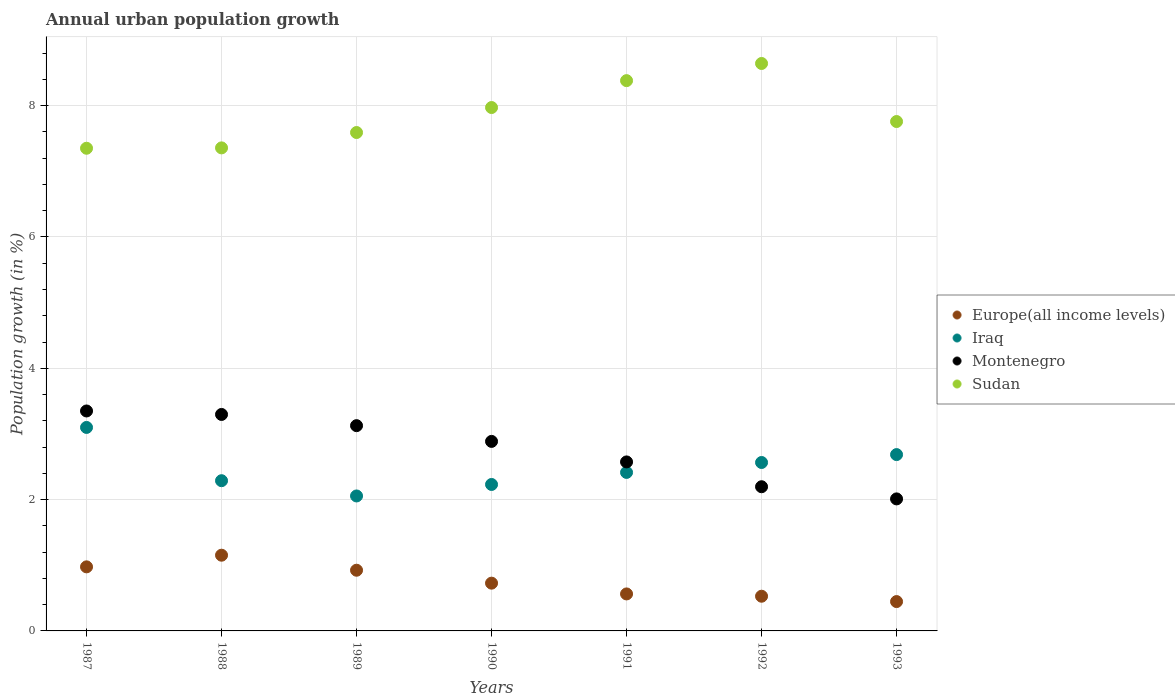Is the number of dotlines equal to the number of legend labels?
Offer a very short reply. Yes. What is the percentage of urban population growth in Europe(all income levels) in 1993?
Your response must be concise. 0.45. Across all years, what is the maximum percentage of urban population growth in Sudan?
Keep it short and to the point. 8.64. Across all years, what is the minimum percentage of urban population growth in Iraq?
Keep it short and to the point. 2.06. In which year was the percentage of urban population growth in Europe(all income levels) maximum?
Your response must be concise. 1988. In which year was the percentage of urban population growth in Montenegro minimum?
Ensure brevity in your answer.  1993. What is the total percentage of urban population growth in Iraq in the graph?
Your answer should be very brief. 17.34. What is the difference between the percentage of urban population growth in Montenegro in 1989 and that in 1990?
Keep it short and to the point. 0.24. What is the difference between the percentage of urban population growth in Iraq in 1989 and the percentage of urban population growth in Montenegro in 1987?
Your answer should be very brief. -1.29. What is the average percentage of urban population growth in Sudan per year?
Ensure brevity in your answer.  7.86. In the year 1988, what is the difference between the percentage of urban population growth in Sudan and percentage of urban population growth in Europe(all income levels)?
Offer a terse response. 6.2. What is the ratio of the percentage of urban population growth in Montenegro in 1987 to that in 1992?
Keep it short and to the point. 1.53. Is the difference between the percentage of urban population growth in Sudan in 1989 and 1993 greater than the difference between the percentage of urban population growth in Europe(all income levels) in 1989 and 1993?
Your answer should be compact. No. What is the difference between the highest and the second highest percentage of urban population growth in Montenegro?
Offer a terse response. 0.05. What is the difference between the highest and the lowest percentage of urban population growth in Sudan?
Keep it short and to the point. 1.29. Is it the case that in every year, the sum of the percentage of urban population growth in Montenegro and percentage of urban population growth in Iraq  is greater than the sum of percentage of urban population growth in Sudan and percentage of urban population growth in Europe(all income levels)?
Your response must be concise. Yes. Is it the case that in every year, the sum of the percentage of urban population growth in Sudan and percentage of urban population growth in Europe(all income levels)  is greater than the percentage of urban population growth in Montenegro?
Provide a short and direct response. Yes. Does the percentage of urban population growth in Sudan monotonically increase over the years?
Provide a succinct answer. No. Is the percentage of urban population growth in Montenegro strictly greater than the percentage of urban population growth in Europe(all income levels) over the years?
Provide a succinct answer. Yes. How many dotlines are there?
Your response must be concise. 4. Are the values on the major ticks of Y-axis written in scientific E-notation?
Offer a terse response. No. Does the graph contain any zero values?
Ensure brevity in your answer.  No. Where does the legend appear in the graph?
Your answer should be very brief. Center right. What is the title of the graph?
Offer a very short reply. Annual urban population growth. Does "Kenya" appear as one of the legend labels in the graph?
Offer a terse response. No. What is the label or title of the X-axis?
Keep it short and to the point. Years. What is the label or title of the Y-axis?
Your answer should be very brief. Population growth (in %). What is the Population growth (in %) of Europe(all income levels) in 1987?
Your answer should be compact. 0.98. What is the Population growth (in %) of Iraq in 1987?
Provide a short and direct response. 3.1. What is the Population growth (in %) of Montenegro in 1987?
Offer a terse response. 3.35. What is the Population growth (in %) of Sudan in 1987?
Give a very brief answer. 7.35. What is the Population growth (in %) of Europe(all income levels) in 1988?
Your response must be concise. 1.15. What is the Population growth (in %) in Iraq in 1988?
Offer a very short reply. 2.29. What is the Population growth (in %) of Montenegro in 1988?
Your answer should be compact. 3.3. What is the Population growth (in %) in Sudan in 1988?
Make the answer very short. 7.36. What is the Population growth (in %) of Europe(all income levels) in 1989?
Offer a very short reply. 0.92. What is the Population growth (in %) in Iraq in 1989?
Provide a short and direct response. 2.06. What is the Population growth (in %) of Montenegro in 1989?
Keep it short and to the point. 3.13. What is the Population growth (in %) in Sudan in 1989?
Give a very brief answer. 7.59. What is the Population growth (in %) in Europe(all income levels) in 1990?
Offer a terse response. 0.73. What is the Population growth (in %) in Iraq in 1990?
Your response must be concise. 2.23. What is the Population growth (in %) of Montenegro in 1990?
Provide a short and direct response. 2.89. What is the Population growth (in %) in Sudan in 1990?
Make the answer very short. 7.97. What is the Population growth (in %) of Europe(all income levels) in 1991?
Your answer should be very brief. 0.56. What is the Population growth (in %) of Iraq in 1991?
Offer a very short reply. 2.41. What is the Population growth (in %) in Montenegro in 1991?
Your answer should be very brief. 2.57. What is the Population growth (in %) of Sudan in 1991?
Offer a very short reply. 8.38. What is the Population growth (in %) of Europe(all income levels) in 1992?
Your answer should be compact. 0.53. What is the Population growth (in %) of Iraq in 1992?
Keep it short and to the point. 2.57. What is the Population growth (in %) in Montenegro in 1992?
Offer a very short reply. 2.2. What is the Population growth (in %) of Sudan in 1992?
Provide a succinct answer. 8.64. What is the Population growth (in %) of Europe(all income levels) in 1993?
Offer a very short reply. 0.45. What is the Population growth (in %) in Iraq in 1993?
Give a very brief answer. 2.69. What is the Population growth (in %) of Montenegro in 1993?
Your answer should be compact. 2.01. What is the Population growth (in %) in Sudan in 1993?
Offer a very short reply. 7.76. Across all years, what is the maximum Population growth (in %) of Europe(all income levels)?
Keep it short and to the point. 1.15. Across all years, what is the maximum Population growth (in %) of Iraq?
Make the answer very short. 3.1. Across all years, what is the maximum Population growth (in %) in Montenegro?
Your answer should be very brief. 3.35. Across all years, what is the maximum Population growth (in %) of Sudan?
Provide a short and direct response. 8.64. Across all years, what is the minimum Population growth (in %) of Europe(all income levels)?
Offer a terse response. 0.45. Across all years, what is the minimum Population growth (in %) of Iraq?
Your response must be concise. 2.06. Across all years, what is the minimum Population growth (in %) of Montenegro?
Offer a terse response. 2.01. Across all years, what is the minimum Population growth (in %) in Sudan?
Your answer should be very brief. 7.35. What is the total Population growth (in %) of Europe(all income levels) in the graph?
Your response must be concise. 5.32. What is the total Population growth (in %) in Iraq in the graph?
Keep it short and to the point. 17.34. What is the total Population growth (in %) in Montenegro in the graph?
Your answer should be compact. 19.44. What is the total Population growth (in %) in Sudan in the graph?
Provide a succinct answer. 55.05. What is the difference between the Population growth (in %) in Europe(all income levels) in 1987 and that in 1988?
Provide a succinct answer. -0.18. What is the difference between the Population growth (in %) of Iraq in 1987 and that in 1988?
Make the answer very short. 0.81. What is the difference between the Population growth (in %) of Montenegro in 1987 and that in 1988?
Your answer should be very brief. 0.05. What is the difference between the Population growth (in %) of Sudan in 1987 and that in 1988?
Give a very brief answer. -0.01. What is the difference between the Population growth (in %) in Europe(all income levels) in 1987 and that in 1989?
Provide a short and direct response. 0.05. What is the difference between the Population growth (in %) of Iraq in 1987 and that in 1989?
Ensure brevity in your answer.  1.04. What is the difference between the Population growth (in %) of Montenegro in 1987 and that in 1989?
Your response must be concise. 0.22. What is the difference between the Population growth (in %) in Sudan in 1987 and that in 1989?
Keep it short and to the point. -0.24. What is the difference between the Population growth (in %) in Europe(all income levels) in 1987 and that in 1990?
Your answer should be very brief. 0.25. What is the difference between the Population growth (in %) in Iraq in 1987 and that in 1990?
Your answer should be very brief. 0.87. What is the difference between the Population growth (in %) of Montenegro in 1987 and that in 1990?
Your answer should be very brief. 0.46. What is the difference between the Population growth (in %) in Sudan in 1987 and that in 1990?
Offer a very short reply. -0.62. What is the difference between the Population growth (in %) of Europe(all income levels) in 1987 and that in 1991?
Keep it short and to the point. 0.41. What is the difference between the Population growth (in %) in Iraq in 1987 and that in 1991?
Give a very brief answer. 0.69. What is the difference between the Population growth (in %) of Montenegro in 1987 and that in 1991?
Your answer should be very brief. 0.78. What is the difference between the Population growth (in %) of Sudan in 1987 and that in 1991?
Your answer should be compact. -1.03. What is the difference between the Population growth (in %) of Europe(all income levels) in 1987 and that in 1992?
Make the answer very short. 0.45. What is the difference between the Population growth (in %) in Iraq in 1987 and that in 1992?
Keep it short and to the point. 0.53. What is the difference between the Population growth (in %) in Montenegro in 1987 and that in 1992?
Your response must be concise. 1.15. What is the difference between the Population growth (in %) of Sudan in 1987 and that in 1992?
Your answer should be compact. -1.29. What is the difference between the Population growth (in %) in Europe(all income levels) in 1987 and that in 1993?
Ensure brevity in your answer.  0.53. What is the difference between the Population growth (in %) of Iraq in 1987 and that in 1993?
Offer a terse response. 0.41. What is the difference between the Population growth (in %) of Montenegro in 1987 and that in 1993?
Keep it short and to the point. 1.34. What is the difference between the Population growth (in %) in Sudan in 1987 and that in 1993?
Offer a very short reply. -0.41. What is the difference between the Population growth (in %) in Europe(all income levels) in 1988 and that in 1989?
Keep it short and to the point. 0.23. What is the difference between the Population growth (in %) in Iraq in 1988 and that in 1989?
Your answer should be very brief. 0.23. What is the difference between the Population growth (in %) in Montenegro in 1988 and that in 1989?
Your response must be concise. 0.17. What is the difference between the Population growth (in %) in Sudan in 1988 and that in 1989?
Your answer should be very brief. -0.23. What is the difference between the Population growth (in %) in Europe(all income levels) in 1988 and that in 1990?
Offer a terse response. 0.43. What is the difference between the Population growth (in %) of Iraq in 1988 and that in 1990?
Offer a terse response. 0.06. What is the difference between the Population growth (in %) in Montenegro in 1988 and that in 1990?
Your answer should be compact. 0.41. What is the difference between the Population growth (in %) in Sudan in 1988 and that in 1990?
Provide a short and direct response. -0.61. What is the difference between the Population growth (in %) in Europe(all income levels) in 1988 and that in 1991?
Give a very brief answer. 0.59. What is the difference between the Population growth (in %) of Iraq in 1988 and that in 1991?
Provide a short and direct response. -0.13. What is the difference between the Population growth (in %) in Montenegro in 1988 and that in 1991?
Provide a short and direct response. 0.72. What is the difference between the Population growth (in %) of Sudan in 1988 and that in 1991?
Your answer should be very brief. -1.02. What is the difference between the Population growth (in %) of Europe(all income levels) in 1988 and that in 1992?
Keep it short and to the point. 0.62. What is the difference between the Population growth (in %) in Iraq in 1988 and that in 1992?
Your response must be concise. -0.28. What is the difference between the Population growth (in %) of Montenegro in 1988 and that in 1992?
Your answer should be very brief. 1.1. What is the difference between the Population growth (in %) in Sudan in 1988 and that in 1992?
Keep it short and to the point. -1.29. What is the difference between the Population growth (in %) in Europe(all income levels) in 1988 and that in 1993?
Make the answer very short. 0.71. What is the difference between the Population growth (in %) of Iraq in 1988 and that in 1993?
Ensure brevity in your answer.  -0.4. What is the difference between the Population growth (in %) of Montenegro in 1988 and that in 1993?
Ensure brevity in your answer.  1.29. What is the difference between the Population growth (in %) of Sudan in 1988 and that in 1993?
Give a very brief answer. -0.4. What is the difference between the Population growth (in %) of Europe(all income levels) in 1989 and that in 1990?
Offer a very short reply. 0.2. What is the difference between the Population growth (in %) in Iraq in 1989 and that in 1990?
Offer a terse response. -0.17. What is the difference between the Population growth (in %) in Montenegro in 1989 and that in 1990?
Give a very brief answer. 0.24. What is the difference between the Population growth (in %) in Sudan in 1989 and that in 1990?
Your answer should be very brief. -0.38. What is the difference between the Population growth (in %) in Europe(all income levels) in 1989 and that in 1991?
Provide a short and direct response. 0.36. What is the difference between the Population growth (in %) of Iraq in 1989 and that in 1991?
Provide a short and direct response. -0.36. What is the difference between the Population growth (in %) of Montenegro in 1989 and that in 1991?
Offer a terse response. 0.55. What is the difference between the Population growth (in %) of Sudan in 1989 and that in 1991?
Give a very brief answer. -0.79. What is the difference between the Population growth (in %) in Europe(all income levels) in 1989 and that in 1992?
Ensure brevity in your answer.  0.4. What is the difference between the Population growth (in %) of Iraq in 1989 and that in 1992?
Ensure brevity in your answer.  -0.51. What is the difference between the Population growth (in %) in Montenegro in 1989 and that in 1992?
Give a very brief answer. 0.93. What is the difference between the Population growth (in %) of Sudan in 1989 and that in 1992?
Give a very brief answer. -1.05. What is the difference between the Population growth (in %) in Europe(all income levels) in 1989 and that in 1993?
Provide a short and direct response. 0.48. What is the difference between the Population growth (in %) in Iraq in 1989 and that in 1993?
Your answer should be very brief. -0.63. What is the difference between the Population growth (in %) in Montenegro in 1989 and that in 1993?
Offer a terse response. 1.12. What is the difference between the Population growth (in %) of Sudan in 1989 and that in 1993?
Offer a terse response. -0.17. What is the difference between the Population growth (in %) of Europe(all income levels) in 1990 and that in 1991?
Your answer should be very brief. 0.16. What is the difference between the Population growth (in %) in Iraq in 1990 and that in 1991?
Offer a terse response. -0.18. What is the difference between the Population growth (in %) in Montenegro in 1990 and that in 1991?
Your answer should be very brief. 0.31. What is the difference between the Population growth (in %) of Sudan in 1990 and that in 1991?
Provide a succinct answer. -0.41. What is the difference between the Population growth (in %) in Europe(all income levels) in 1990 and that in 1992?
Provide a succinct answer. 0.2. What is the difference between the Population growth (in %) in Iraq in 1990 and that in 1992?
Provide a succinct answer. -0.33. What is the difference between the Population growth (in %) of Montenegro in 1990 and that in 1992?
Offer a terse response. 0.69. What is the difference between the Population growth (in %) in Sudan in 1990 and that in 1992?
Your answer should be very brief. -0.67. What is the difference between the Population growth (in %) of Europe(all income levels) in 1990 and that in 1993?
Your response must be concise. 0.28. What is the difference between the Population growth (in %) in Iraq in 1990 and that in 1993?
Ensure brevity in your answer.  -0.46. What is the difference between the Population growth (in %) of Montenegro in 1990 and that in 1993?
Ensure brevity in your answer.  0.88. What is the difference between the Population growth (in %) in Sudan in 1990 and that in 1993?
Offer a very short reply. 0.21. What is the difference between the Population growth (in %) of Europe(all income levels) in 1991 and that in 1992?
Keep it short and to the point. 0.03. What is the difference between the Population growth (in %) in Iraq in 1991 and that in 1992?
Offer a terse response. -0.15. What is the difference between the Population growth (in %) in Montenegro in 1991 and that in 1992?
Keep it short and to the point. 0.38. What is the difference between the Population growth (in %) in Sudan in 1991 and that in 1992?
Provide a short and direct response. -0.26. What is the difference between the Population growth (in %) in Europe(all income levels) in 1991 and that in 1993?
Your answer should be compact. 0.12. What is the difference between the Population growth (in %) of Iraq in 1991 and that in 1993?
Make the answer very short. -0.27. What is the difference between the Population growth (in %) of Montenegro in 1991 and that in 1993?
Your answer should be compact. 0.56. What is the difference between the Population growth (in %) in Sudan in 1991 and that in 1993?
Your answer should be very brief. 0.62. What is the difference between the Population growth (in %) of Europe(all income levels) in 1992 and that in 1993?
Provide a short and direct response. 0.08. What is the difference between the Population growth (in %) of Iraq in 1992 and that in 1993?
Ensure brevity in your answer.  -0.12. What is the difference between the Population growth (in %) of Montenegro in 1992 and that in 1993?
Make the answer very short. 0.19. What is the difference between the Population growth (in %) of Sudan in 1992 and that in 1993?
Offer a terse response. 0.88. What is the difference between the Population growth (in %) in Europe(all income levels) in 1987 and the Population growth (in %) in Iraq in 1988?
Offer a terse response. -1.31. What is the difference between the Population growth (in %) in Europe(all income levels) in 1987 and the Population growth (in %) in Montenegro in 1988?
Your answer should be very brief. -2.32. What is the difference between the Population growth (in %) in Europe(all income levels) in 1987 and the Population growth (in %) in Sudan in 1988?
Your answer should be very brief. -6.38. What is the difference between the Population growth (in %) of Iraq in 1987 and the Population growth (in %) of Montenegro in 1988?
Provide a succinct answer. -0.2. What is the difference between the Population growth (in %) of Iraq in 1987 and the Population growth (in %) of Sudan in 1988?
Offer a terse response. -4.26. What is the difference between the Population growth (in %) of Montenegro in 1987 and the Population growth (in %) of Sudan in 1988?
Offer a terse response. -4.01. What is the difference between the Population growth (in %) in Europe(all income levels) in 1987 and the Population growth (in %) in Iraq in 1989?
Provide a succinct answer. -1.08. What is the difference between the Population growth (in %) of Europe(all income levels) in 1987 and the Population growth (in %) of Montenegro in 1989?
Provide a short and direct response. -2.15. What is the difference between the Population growth (in %) of Europe(all income levels) in 1987 and the Population growth (in %) of Sudan in 1989?
Offer a terse response. -6.61. What is the difference between the Population growth (in %) of Iraq in 1987 and the Population growth (in %) of Montenegro in 1989?
Your answer should be very brief. -0.03. What is the difference between the Population growth (in %) of Iraq in 1987 and the Population growth (in %) of Sudan in 1989?
Your response must be concise. -4.49. What is the difference between the Population growth (in %) of Montenegro in 1987 and the Population growth (in %) of Sudan in 1989?
Offer a terse response. -4.24. What is the difference between the Population growth (in %) in Europe(all income levels) in 1987 and the Population growth (in %) in Iraq in 1990?
Your response must be concise. -1.25. What is the difference between the Population growth (in %) of Europe(all income levels) in 1987 and the Population growth (in %) of Montenegro in 1990?
Provide a succinct answer. -1.91. What is the difference between the Population growth (in %) of Europe(all income levels) in 1987 and the Population growth (in %) of Sudan in 1990?
Offer a terse response. -7. What is the difference between the Population growth (in %) in Iraq in 1987 and the Population growth (in %) in Montenegro in 1990?
Your answer should be very brief. 0.21. What is the difference between the Population growth (in %) in Iraq in 1987 and the Population growth (in %) in Sudan in 1990?
Make the answer very short. -4.87. What is the difference between the Population growth (in %) of Montenegro in 1987 and the Population growth (in %) of Sudan in 1990?
Keep it short and to the point. -4.62. What is the difference between the Population growth (in %) in Europe(all income levels) in 1987 and the Population growth (in %) in Iraq in 1991?
Provide a short and direct response. -1.44. What is the difference between the Population growth (in %) of Europe(all income levels) in 1987 and the Population growth (in %) of Montenegro in 1991?
Provide a short and direct response. -1.6. What is the difference between the Population growth (in %) in Europe(all income levels) in 1987 and the Population growth (in %) in Sudan in 1991?
Ensure brevity in your answer.  -7.41. What is the difference between the Population growth (in %) of Iraq in 1987 and the Population growth (in %) of Montenegro in 1991?
Your response must be concise. 0.53. What is the difference between the Population growth (in %) in Iraq in 1987 and the Population growth (in %) in Sudan in 1991?
Keep it short and to the point. -5.28. What is the difference between the Population growth (in %) in Montenegro in 1987 and the Population growth (in %) in Sudan in 1991?
Ensure brevity in your answer.  -5.03. What is the difference between the Population growth (in %) of Europe(all income levels) in 1987 and the Population growth (in %) of Iraq in 1992?
Ensure brevity in your answer.  -1.59. What is the difference between the Population growth (in %) of Europe(all income levels) in 1987 and the Population growth (in %) of Montenegro in 1992?
Offer a terse response. -1.22. What is the difference between the Population growth (in %) of Europe(all income levels) in 1987 and the Population growth (in %) of Sudan in 1992?
Your answer should be very brief. -7.67. What is the difference between the Population growth (in %) in Iraq in 1987 and the Population growth (in %) in Montenegro in 1992?
Your answer should be very brief. 0.9. What is the difference between the Population growth (in %) of Iraq in 1987 and the Population growth (in %) of Sudan in 1992?
Make the answer very short. -5.54. What is the difference between the Population growth (in %) of Montenegro in 1987 and the Population growth (in %) of Sudan in 1992?
Ensure brevity in your answer.  -5.29. What is the difference between the Population growth (in %) of Europe(all income levels) in 1987 and the Population growth (in %) of Iraq in 1993?
Provide a succinct answer. -1.71. What is the difference between the Population growth (in %) of Europe(all income levels) in 1987 and the Population growth (in %) of Montenegro in 1993?
Your answer should be very brief. -1.03. What is the difference between the Population growth (in %) of Europe(all income levels) in 1987 and the Population growth (in %) of Sudan in 1993?
Ensure brevity in your answer.  -6.78. What is the difference between the Population growth (in %) of Iraq in 1987 and the Population growth (in %) of Montenegro in 1993?
Your response must be concise. 1.09. What is the difference between the Population growth (in %) in Iraq in 1987 and the Population growth (in %) in Sudan in 1993?
Your response must be concise. -4.66. What is the difference between the Population growth (in %) in Montenegro in 1987 and the Population growth (in %) in Sudan in 1993?
Your response must be concise. -4.41. What is the difference between the Population growth (in %) in Europe(all income levels) in 1988 and the Population growth (in %) in Iraq in 1989?
Your response must be concise. -0.9. What is the difference between the Population growth (in %) in Europe(all income levels) in 1988 and the Population growth (in %) in Montenegro in 1989?
Your answer should be compact. -1.97. What is the difference between the Population growth (in %) in Europe(all income levels) in 1988 and the Population growth (in %) in Sudan in 1989?
Your answer should be compact. -6.44. What is the difference between the Population growth (in %) in Iraq in 1988 and the Population growth (in %) in Montenegro in 1989?
Make the answer very short. -0.84. What is the difference between the Population growth (in %) in Iraq in 1988 and the Population growth (in %) in Sudan in 1989?
Give a very brief answer. -5.3. What is the difference between the Population growth (in %) in Montenegro in 1988 and the Population growth (in %) in Sudan in 1989?
Provide a short and direct response. -4.29. What is the difference between the Population growth (in %) in Europe(all income levels) in 1988 and the Population growth (in %) in Iraq in 1990?
Give a very brief answer. -1.08. What is the difference between the Population growth (in %) of Europe(all income levels) in 1988 and the Population growth (in %) of Montenegro in 1990?
Offer a terse response. -1.73. What is the difference between the Population growth (in %) in Europe(all income levels) in 1988 and the Population growth (in %) in Sudan in 1990?
Ensure brevity in your answer.  -6.82. What is the difference between the Population growth (in %) in Iraq in 1988 and the Population growth (in %) in Montenegro in 1990?
Your answer should be very brief. -0.6. What is the difference between the Population growth (in %) of Iraq in 1988 and the Population growth (in %) of Sudan in 1990?
Your response must be concise. -5.68. What is the difference between the Population growth (in %) in Montenegro in 1988 and the Population growth (in %) in Sudan in 1990?
Make the answer very short. -4.67. What is the difference between the Population growth (in %) in Europe(all income levels) in 1988 and the Population growth (in %) in Iraq in 1991?
Your answer should be compact. -1.26. What is the difference between the Population growth (in %) in Europe(all income levels) in 1988 and the Population growth (in %) in Montenegro in 1991?
Provide a succinct answer. -1.42. What is the difference between the Population growth (in %) of Europe(all income levels) in 1988 and the Population growth (in %) of Sudan in 1991?
Give a very brief answer. -7.23. What is the difference between the Population growth (in %) of Iraq in 1988 and the Population growth (in %) of Montenegro in 1991?
Your answer should be very brief. -0.29. What is the difference between the Population growth (in %) of Iraq in 1988 and the Population growth (in %) of Sudan in 1991?
Your response must be concise. -6.09. What is the difference between the Population growth (in %) of Montenegro in 1988 and the Population growth (in %) of Sudan in 1991?
Make the answer very short. -5.08. What is the difference between the Population growth (in %) of Europe(all income levels) in 1988 and the Population growth (in %) of Iraq in 1992?
Make the answer very short. -1.41. What is the difference between the Population growth (in %) in Europe(all income levels) in 1988 and the Population growth (in %) in Montenegro in 1992?
Keep it short and to the point. -1.04. What is the difference between the Population growth (in %) of Europe(all income levels) in 1988 and the Population growth (in %) of Sudan in 1992?
Provide a short and direct response. -7.49. What is the difference between the Population growth (in %) of Iraq in 1988 and the Population growth (in %) of Montenegro in 1992?
Provide a succinct answer. 0.09. What is the difference between the Population growth (in %) in Iraq in 1988 and the Population growth (in %) in Sudan in 1992?
Your answer should be compact. -6.35. What is the difference between the Population growth (in %) in Montenegro in 1988 and the Population growth (in %) in Sudan in 1992?
Provide a short and direct response. -5.35. What is the difference between the Population growth (in %) in Europe(all income levels) in 1988 and the Population growth (in %) in Iraq in 1993?
Give a very brief answer. -1.53. What is the difference between the Population growth (in %) of Europe(all income levels) in 1988 and the Population growth (in %) of Montenegro in 1993?
Your answer should be very brief. -0.86. What is the difference between the Population growth (in %) of Europe(all income levels) in 1988 and the Population growth (in %) of Sudan in 1993?
Ensure brevity in your answer.  -6.6. What is the difference between the Population growth (in %) of Iraq in 1988 and the Population growth (in %) of Montenegro in 1993?
Keep it short and to the point. 0.28. What is the difference between the Population growth (in %) in Iraq in 1988 and the Population growth (in %) in Sudan in 1993?
Ensure brevity in your answer.  -5.47. What is the difference between the Population growth (in %) in Montenegro in 1988 and the Population growth (in %) in Sudan in 1993?
Give a very brief answer. -4.46. What is the difference between the Population growth (in %) in Europe(all income levels) in 1989 and the Population growth (in %) in Iraq in 1990?
Offer a very short reply. -1.31. What is the difference between the Population growth (in %) of Europe(all income levels) in 1989 and the Population growth (in %) of Montenegro in 1990?
Make the answer very short. -1.96. What is the difference between the Population growth (in %) in Europe(all income levels) in 1989 and the Population growth (in %) in Sudan in 1990?
Your response must be concise. -7.05. What is the difference between the Population growth (in %) of Iraq in 1989 and the Population growth (in %) of Montenegro in 1990?
Ensure brevity in your answer.  -0.83. What is the difference between the Population growth (in %) of Iraq in 1989 and the Population growth (in %) of Sudan in 1990?
Your answer should be very brief. -5.92. What is the difference between the Population growth (in %) in Montenegro in 1989 and the Population growth (in %) in Sudan in 1990?
Ensure brevity in your answer.  -4.85. What is the difference between the Population growth (in %) in Europe(all income levels) in 1989 and the Population growth (in %) in Iraq in 1991?
Keep it short and to the point. -1.49. What is the difference between the Population growth (in %) in Europe(all income levels) in 1989 and the Population growth (in %) in Montenegro in 1991?
Offer a terse response. -1.65. What is the difference between the Population growth (in %) of Europe(all income levels) in 1989 and the Population growth (in %) of Sudan in 1991?
Give a very brief answer. -7.46. What is the difference between the Population growth (in %) in Iraq in 1989 and the Population growth (in %) in Montenegro in 1991?
Ensure brevity in your answer.  -0.52. What is the difference between the Population growth (in %) of Iraq in 1989 and the Population growth (in %) of Sudan in 1991?
Provide a succinct answer. -6.33. What is the difference between the Population growth (in %) of Montenegro in 1989 and the Population growth (in %) of Sudan in 1991?
Give a very brief answer. -5.25. What is the difference between the Population growth (in %) in Europe(all income levels) in 1989 and the Population growth (in %) in Iraq in 1992?
Give a very brief answer. -1.64. What is the difference between the Population growth (in %) in Europe(all income levels) in 1989 and the Population growth (in %) in Montenegro in 1992?
Ensure brevity in your answer.  -1.27. What is the difference between the Population growth (in %) in Europe(all income levels) in 1989 and the Population growth (in %) in Sudan in 1992?
Keep it short and to the point. -7.72. What is the difference between the Population growth (in %) of Iraq in 1989 and the Population growth (in %) of Montenegro in 1992?
Ensure brevity in your answer.  -0.14. What is the difference between the Population growth (in %) of Iraq in 1989 and the Population growth (in %) of Sudan in 1992?
Provide a succinct answer. -6.59. What is the difference between the Population growth (in %) in Montenegro in 1989 and the Population growth (in %) in Sudan in 1992?
Give a very brief answer. -5.52. What is the difference between the Population growth (in %) of Europe(all income levels) in 1989 and the Population growth (in %) of Iraq in 1993?
Your answer should be compact. -1.76. What is the difference between the Population growth (in %) of Europe(all income levels) in 1989 and the Population growth (in %) of Montenegro in 1993?
Your answer should be compact. -1.09. What is the difference between the Population growth (in %) of Europe(all income levels) in 1989 and the Population growth (in %) of Sudan in 1993?
Offer a terse response. -6.83. What is the difference between the Population growth (in %) in Iraq in 1989 and the Population growth (in %) in Montenegro in 1993?
Make the answer very short. 0.04. What is the difference between the Population growth (in %) of Iraq in 1989 and the Population growth (in %) of Sudan in 1993?
Keep it short and to the point. -5.7. What is the difference between the Population growth (in %) of Montenegro in 1989 and the Population growth (in %) of Sudan in 1993?
Give a very brief answer. -4.63. What is the difference between the Population growth (in %) of Europe(all income levels) in 1990 and the Population growth (in %) of Iraq in 1991?
Give a very brief answer. -1.69. What is the difference between the Population growth (in %) of Europe(all income levels) in 1990 and the Population growth (in %) of Montenegro in 1991?
Your answer should be compact. -1.85. What is the difference between the Population growth (in %) of Europe(all income levels) in 1990 and the Population growth (in %) of Sudan in 1991?
Keep it short and to the point. -7.65. What is the difference between the Population growth (in %) of Iraq in 1990 and the Population growth (in %) of Montenegro in 1991?
Offer a very short reply. -0.34. What is the difference between the Population growth (in %) of Iraq in 1990 and the Population growth (in %) of Sudan in 1991?
Give a very brief answer. -6.15. What is the difference between the Population growth (in %) in Montenegro in 1990 and the Population growth (in %) in Sudan in 1991?
Your answer should be very brief. -5.49. What is the difference between the Population growth (in %) in Europe(all income levels) in 1990 and the Population growth (in %) in Iraq in 1992?
Make the answer very short. -1.84. What is the difference between the Population growth (in %) of Europe(all income levels) in 1990 and the Population growth (in %) of Montenegro in 1992?
Keep it short and to the point. -1.47. What is the difference between the Population growth (in %) of Europe(all income levels) in 1990 and the Population growth (in %) of Sudan in 1992?
Your answer should be very brief. -7.91. What is the difference between the Population growth (in %) in Iraq in 1990 and the Population growth (in %) in Montenegro in 1992?
Provide a succinct answer. 0.03. What is the difference between the Population growth (in %) in Iraq in 1990 and the Population growth (in %) in Sudan in 1992?
Provide a succinct answer. -6.41. What is the difference between the Population growth (in %) in Montenegro in 1990 and the Population growth (in %) in Sudan in 1992?
Your response must be concise. -5.76. What is the difference between the Population growth (in %) in Europe(all income levels) in 1990 and the Population growth (in %) in Iraq in 1993?
Keep it short and to the point. -1.96. What is the difference between the Population growth (in %) of Europe(all income levels) in 1990 and the Population growth (in %) of Montenegro in 1993?
Offer a terse response. -1.28. What is the difference between the Population growth (in %) of Europe(all income levels) in 1990 and the Population growth (in %) of Sudan in 1993?
Your answer should be compact. -7.03. What is the difference between the Population growth (in %) in Iraq in 1990 and the Population growth (in %) in Montenegro in 1993?
Keep it short and to the point. 0.22. What is the difference between the Population growth (in %) in Iraq in 1990 and the Population growth (in %) in Sudan in 1993?
Your response must be concise. -5.53. What is the difference between the Population growth (in %) of Montenegro in 1990 and the Population growth (in %) of Sudan in 1993?
Offer a terse response. -4.87. What is the difference between the Population growth (in %) of Europe(all income levels) in 1991 and the Population growth (in %) of Iraq in 1992?
Offer a terse response. -2. What is the difference between the Population growth (in %) in Europe(all income levels) in 1991 and the Population growth (in %) in Montenegro in 1992?
Provide a short and direct response. -1.63. What is the difference between the Population growth (in %) of Europe(all income levels) in 1991 and the Population growth (in %) of Sudan in 1992?
Ensure brevity in your answer.  -8.08. What is the difference between the Population growth (in %) in Iraq in 1991 and the Population growth (in %) in Montenegro in 1992?
Provide a short and direct response. 0.22. What is the difference between the Population growth (in %) of Iraq in 1991 and the Population growth (in %) of Sudan in 1992?
Offer a very short reply. -6.23. What is the difference between the Population growth (in %) of Montenegro in 1991 and the Population growth (in %) of Sudan in 1992?
Give a very brief answer. -6.07. What is the difference between the Population growth (in %) in Europe(all income levels) in 1991 and the Population growth (in %) in Iraq in 1993?
Provide a succinct answer. -2.12. What is the difference between the Population growth (in %) in Europe(all income levels) in 1991 and the Population growth (in %) in Montenegro in 1993?
Make the answer very short. -1.45. What is the difference between the Population growth (in %) of Europe(all income levels) in 1991 and the Population growth (in %) of Sudan in 1993?
Your answer should be compact. -7.19. What is the difference between the Population growth (in %) in Iraq in 1991 and the Population growth (in %) in Montenegro in 1993?
Keep it short and to the point. 0.4. What is the difference between the Population growth (in %) in Iraq in 1991 and the Population growth (in %) in Sudan in 1993?
Ensure brevity in your answer.  -5.34. What is the difference between the Population growth (in %) in Montenegro in 1991 and the Population growth (in %) in Sudan in 1993?
Your response must be concise. -5.18. What is the difference between the Population growth (in %) of Europe(all income levels) in 1992 and the Population growth (in %) of Iraq in 1993?
Your response must be concise. -2.16. What is the difference between the Population growth (in %) of Europe(all income levels) in 1992 and the Population growth (in %) of Montenegro in 1993?
Your response must be concise. -1.48. What is the difference between the Population growth (in %) in Europe(all income levels) in 1992 and the Population growth (in %) in Sudan in 1993?
Your answer should be very brief. -7.23. What is the difference between the Population growth (in %) in Iraq in 1992 and the Population growth (in %) in Montenegro in 1993?
Your answer should be very brief. 0.55. What is the difference between the Population growth (in %) of Iraq in 1992 and the Population growth (in %) of Sudan in 1993?
Keep it short and to the point. -5.19. What is the difference between the Population growth (in %) of Montenegro in 1992 and the Population growth (in %) of Sudan in 1993?
Offer a terse response. -5.56. What is the average Population growth (in %) of Europe(all income levels) per year?
Keep it short and to the point. 0.76. What is the average Population growth (in %) of Iraq per year?
Keep it short and to the point. 2.48. What is the average Population growth (in %) in Montenegro per year?
Provide a short and direct response. 2.78. What is the average Population growth (in %) of Sudan per year?
Ensure brevity in your answer.  7.86. In the year 1987, what is the difference between the Population growth (in %) in Europe(all income levels) and Population growth (in %) in Iraq?
Ensure brevity in your answer.  -2.12. In the year 1987, what is the difference between the Population growth (in %) of Europe(all income levels) and Population growth (in %) of Montenegro?
Offer a very short reply. -2.37. In the year 1987, what is the difference between the Population growth (in %) of Europe(all income levels) and Population growth (in %) of Sudan?
Provide a short and direct response. -6.38. In the year 1987, what is the difference between the Population growth (in %) in Iraq and Population growth (in %) in Montenegro?
Provide a succinct answer. -0.25. In the year 1987, what is the difference between the Population growth (in %) in Iraq and Population growth (in %) in Sudan?
Ensure brevity in your answer.  -4.25. In the year 1987, what is the difference between the Population growth (in %) of Montenegro and Population growth (in %) of Sudan?
Offer a terse response. -4. In the year 1988, what is the difference between the Population growth (in %) in Europe(all income levels) and Population growth (in %) in Iraq?
Your answer should be very brief. -1.13. In the year 1988, what is the difference between the Population growth (in %) of Europe(all income levels) and Population growth (in %) of Montenegro?
Your response must be concise. -2.14. In the year 1988, what is the difference between the Population growth (in %) in Europe(all income levels) and Population growth (in %) in Sudan?
Your response must be concise. -6.2. In the year 1988, what is the difference between the Population growth (in %) in Iraq and Population growth (in %) in Montenegro?
Offer a very short reply. -1.01. In the year 1988, what is the difference between the Population growth (in %) of Iraq and Population growth (in %) of Sudan?
Your response must be concise. -5.07. In the year 1988, what is the difference between the Population growth (in %) in Montenegro and Population growth (in %) in Sudan?
Give a very brief answer. -4.06. In the year 1989, what is the difference between the Population growth (in %) of Europe(all income levels) and Population growth (in %) of Iraq?
Your response must be concise. -1.13. In the year 1989, what is the difference between the Population growth (in %) in Europe(all income levels) and Population growth (in %) in Montenegro?
Keep it short and to the point. -2.2. In the year 1989, what is the difference between the Population growth (in %) of Europe(all income levels) and Population growth (in %) of Sudan?
Keep it short and to the point. -6.67. In the year 1989, what is the difference between the Population growth (in %) of Iraq and Population growth (in %) of Montenegro?
Offer a terse response. -1.07. In the year 1989, what is the difference between the Population growth (in %) in Iraq and Population growth (in %) in Sudan?
Make the answer very short. -5.54. In the year 1989, what is the difference between the Population growth (in %) of Montenegro and Population growth (in %) of Sudan?
Provide a succinct answer. -4.46. In the year 1990, what is the difference between the Population growth (in %) in Europe(all income levels) and Population growth (in %) in Iraq?
Your answer should be very brief. -1.5. In the year 1990, what is the difference between the Population growth (in %) of Europe(all income levels) and Population growth (in %) of Montenegro?
Provide a succinct answer. -2.16. In the year 1990, what is the difference between the Population growth (in %) of Europe(all income levels) and Population growth (in %) of Sudan?
Provide a succinct answer. -7.24. In the year 1990, what is the difference between the Population growth (in %) in Iraq and Population growth (in %) in Montenegro?
Keep it short and to the point. -0.66. In the year 1990, what is the difference between the Population growth (in %) in Iraq and Population growth (in %) in Sudan?
Your response must be concise. -5.74. In the year 1990, what is the difference between the Population growth (in %) in Montenegro and Population growth (in %) in Sudan?
Provide a short and direct response. -5.08. In the year 1991, what is the difference between the Population growth (in %) of Europe(all income levels) and Population growth (in %) of Iraq?
Provide a succinct answer. -1.85. In the year 1991, what is the difference between the Population growth (in %) of Europe(all income levels) and Population growth (in %) of Montenegro?
Keep it short and to the point. -2.01. In the year 1991, what is the difference between the Population growth (in %) in Europe(all income levels) and Population growth (in %) in Sudan?
Your response must be concise. -7.82. In the year 1991, what is the difference between the Population growth (in %) in Iraq and Population growth (in %) in Montenegro?
Provide a succinct answer. -0.16. In the year 1991, what is the difference between the Population growth (in %) of Iraq and Population growth (in %) of Sudan?
Offer a terse response. -5.97. In the year 1991, what is the difference between the Population growth (in %) in Montenegro and Population growth (in %) in Sudan?
Your answer should be very brief. -5.81. In the year 1992, what is the difference between the Population growth (in %) in Europe(all income levels) and Population growth (in %) in Iraq?
Ensure brevity in your answer.  -2.04. In the year 1992, what is the difference between the Population growth (in %) in Europe(all income levels) and Population growth (in %) in Montenegro?
Your answer should be compact. -1.67. In the year 1992, what is the difference between the Population growth (in %) of Europe(all income levels) and Population growth (in %) of Sudan?
Keep it short and to the point. -8.11. In the year 1992, what is the difference between the Population growth (in %) in Iraq and Population growth (in %) in Montenegro?
Keep it short and to the point. 0.37. In the year 1992, what is the difference between the Population growth (in %) of Iraq and Population growth (in %) of Sudan?
Offer a terse response. -6.08. In the year 1992, what is the difference between the Population growth (in %) in Montenegro and Population growth (in %) in Sudan?
Offer a terse response. -6.45. In the year 1993, what is the difference between the Population growth (in %) of Europe(all income levels) and Population growth (in %) of Iraq?
Make the answer very short. -2.24. In the year 1993, what is the difference between the Population growth (in %) in Europe(all income levels) and Population growth (in %) in Montenegro?
Your response must be concise. -1.56. In the year 1993, what is the difference between the Population growth (in %) of Europe(all income levels) and Population growth (in %) of Sudan?
Offer a terse response. -7.31. In the year 1993, what is the difference between the Population growth (in %) of Iraq and Population growth (in %) of Montenegro?
Offer a terse response. 0.67. In the year 1993, what is the difference between the Population growth (in %) in Iraq and Population growth (in %) in Sudan?
Provide a succinct answer. -5.07. In the year 1993, what is the difference between the Population growth (in %) of Montenegro and Population growth (in %) of Sudan?
Your answer should be compact. -5.75. What is the ratio of the Population growth (in %) of Europe(all income levels) in 1987 to that in 1988?
Your response must be concise. 0.85. What is the ratio of the Population growth (in %) of Iraq in 1987 to that in 1988?
Offer a terse response. 1.35. What is the ratio of the Population growth (in %) of Montenegro in 1987 to that in 1988?
Give a very brief answer. 1.02. What is the ratio of the Population growth (in %) of Europe(all income levels) in 1987 to that in 1989?
Keep it short and to the point. 1.06. What is the ratio of the Population growth (in %) in Iraq in 1987 to that in 1989?
Offer a very short reply. 1.51. What is the ratio of the Population growth (in %) in Montenegro in 1987 to that in 1989?
Give a very brief answer. 1.07. What is the ratio of the Population growth (in %) of Sudan in 1987 to that in 1989?
Provide a short and direct response. 0.97. What is the ratio of the Population growth (in %) of Europe(all income levels) in 1987 to that in 1990?
Provide a succinct answer. 1.34. What is the ratio of the Population growth (in %) of Iraq in 1987 to that in 1990?
Your response must be concise. 1.39. What is the ratio of the Population growth (in %) in Montenegro in 1987 to that in 1990?
Ensure brevity in your answer.  1.16. What is the ratio of the Population growth (in %) in Sudan in 1987 to that in 1990?
Ensure brevity in your answer.  0.92. What is the ratio of the Population growth (in %) of Europe(all income levels) in 1987 to that in 1991?
Provide a short and direct response. 1.73. What is the ratio of the Population growth (in %) of Iraq in 1987 to that in 1991?
Ensure brevity in your answer.  1.28. What is the ratio of the Population growth (in %) of Montenegro in 1987 to that in 1991?
Provide a short and direct response. 1.3. What is the ratio of the Population growth (in %) in Sudan in 1987 to that in 1991?
Ensure brevity in your answer.  0.88. What is the ratio of the Population growth (in %) in Europe(all income levels) in 1987 to that in 1992?
Make the answer very short. 1.85. What is the ratio of the Population growth (in %) in Iraq in 1987 to that in 1992?
Your answer should be compact. 1.21. What is the ratio of the Population growth (in %) of Montenegro in 1987 to that in 1992?
Your answer should be very brief. 1.53. What is the ratio of the Population growth (in %) in Sudan in 1987 to that in 1992?
Give a very brief answer. 0.85. What is the ratio of the Population growth (in %) in Europe(all income levels) in 1987 to that in 1993?
Give a very brief answer. 2.18. What is the ratio of the Population growth (in %) in Iraq in 1987 to that in 1993?
Give a very brief answer. 1.15. What is the ratio of the Population growth (in %) in Montenegro in 1987 to that in 1993?
Provide a short and direct response. 1.67. What is the ratio of the Population growth (in %) of Sudan in 1987 to that in 1993?
Offer a very short reply. 0.95. What is the ratio of the Population growth (in %) in Europe(all income levels) in 1988 to that in 1989?
Ensure brevity in your answer.  1.25. What is the ratio of the Population growth (in %) of Iraq in 1988 to that in 1989?
Your response must be concise. 1.11. What is the ratio of the Population growth (in %) in Montenegro in 1988 to that in 1989?
Your answer should be very brief. 1.05. What is the ratio of the Population growth (in %) of Sudan in 1988 to that in 1989?
Your response must be concise. 0.97. What is the ratio of the Population growth (in %) in Europe(all income levels) in 1988 to that in 1990?
Make the answer very short. 1.59. What is the ratio of the Population growth (in %) in Iraq in 1988 to that in 1990?
Provide a succinct answer. 1.03. What is the ratio of the Population growth (in %) in Montenegro in 1988 to that in 1990?
Give a very brief answer. 1.14. What is the ratio of the Population growth (in %) in Sudan in 1988 to that in 1990?
Provide a succinct answer. 0.92. What is the ratio of the Population growth (in %) of Europe(all income levels) in 1988 to that in 1991?
Your response must be concise. 2.05. What is the ratio of the Population growth (in %) of Iraq in 1988 to that in 1991?
Give a very brief answer. 0.95. What is the ratio of the Population growth (in %) in Montenegro in 1988 to that in 1991?
Ensure brevity in your answer.  1.28. What is the ratio of the Population growth (in %) of Sudan in 1988 to that in 1991?
Make the answer very short. 0.88. What is the ratio of the Population growth (in %) of Europe(all income levels) in 1988 to that in 1992?
Make the answer very short. 2.18. What is the ratio of the Population growth (in %) in Iraq in 1988 to that in 1992?
Offer a terse response. 0.89. What is the ratio of the Population growth (in %) in Montenegro in 1988 to that in 1992?
Ensure brevity in your answer.  1.5. What is the ratio of the Population growth (in %) of Sudan in 1988 to that in 1992?
Offer a very short reply. 0.85. What is the ratio of the Population growth (in %) in Europe(all income levels) in 1988 to that in 1993?
Ensure brevity in your answer.  2.58. What is the ratio of the Population growth (in %) of Iraq in 1988 to that in 1993?
Offer a very short reply. 0.85. What is the ratio of the Population growth (in %) in Montenegro in 1988 to that in 1993?
Your answer should be very brief. 1.64. What is the ratio of the Population growth (in %) of Sudan in 1988 to that in 1993?
Offer a terse response. 0.95. What is the ratio of the Population growth (in %) of Europe(all income levels) in 1989 to that in 1990?
Ensure brevity in your answer.  1.27. What is the ratio of the Population growth (in %) in Iraq in 1989 to that in 1990?
Provide a succinct answer. 0.92. What is the ratio of the Population growth (in %) of Montenegro in 1989 to that in 1990?
Ensure brevity in your answer.  1.08. What is the ratio of the Population growth (in %) in Sudan in 1989 to that in 1990?
Provide a short and direct response. 0.95. What is the ratio of the Population growth (in %) in Europe(all income levels) in 1989 to that in 1991?
Offer a terse response. 1.64. What is the ratio of the Population growth (in %) of Iraq in 1989 to that in 1991?
Give a very brief answer. 0.85. What is the ratio of the Population growth (in %) of Montenegro in 1989 to that in 1991?
Offer a very short reply. 1.21. What is the ratio of the Population growth (in %) of Sudan in 1989 to that in 1991?
Offer a terse response. 0.91. What is the ratio of the Population growth (in %) of Europe(all income levels) in 1989 to that in 1992?
Keep it short and to the point. 1.75. What is the ratio of the Population growth (in %) of Iraq in 1989 to that in 1992?
Ensure brevity in your answer.  0.8. What is the ratio of the Population growth (in %) of Montenegro in 1989 to that in 1992?
Provide a short and direct response. 1.42. What is the ratio of the Population growth (in %) in Sudan in 1989 to that in 1992?
Offer a very short reply. 0.88. What is the ratio of the Population growth (in %) of Europe(all income levels) in 1989 to that in 1993?
Ensure brevity in your answer.  2.07. What is the ratio of the Population growth (in %) in Iraq in 1989 to that in 1993?
Provide a succinct answer. 0.77. What is the ratio of the Population growth (in %) in Montenegro in 1989 to that in 1993?
Ensure brevity in your answer.  1.55. What is the ratio of the Population growth (in %) of Sudan in 1989 to that in 1993?
Ensure brevity in your answer.  0.98. What is the ratio of the Population growth (in %) of Europe(all income levels) in 1990 to that in 1991?
Your answer should be very brief. 1.29. What is the ratio of the Population growth (in %) of Iraq in 1990 to that in 1991?
Offer a terse response. 0.92. What is the ratio of the Population growth (in %) of Montenegro in 1990 to that in 1991?
Your answer should be very brief. 1.12. What is the ratio of the Population growth (in %) of Sudan in 1990 to that in 1991?
Your answer should be compact. 0.95. What is the ratio of the Population growth (in %) of Europe(all income levels) in 1990 to that in 1992?
Offer a terse response. 1.38. What is the ratio of the Population growth (in %) in Iraq in 1990 to that in 1992?
Give a very brief answer. 0.87. What is the ratio of the Population growth (in %) of Montenegro in 1990 to that in 1992?
Offer a terse response. 1.31. What is the ratio of the Population growth (in %) of Sudan in 1990 to that in 1992?
Your answer should be very brief. 0.92. What is the ratio of the Population growth (in %) of Europe(all income levels) in 1990 to that in 1993?
Make the answer very short. 1.63. What is the ratio of the Population growth (in %) of Iraq in 1990 to that in 1993?
Give a very brief answer. 0.83. What is the ratio of the Population growth (in %) of Montenegro in 1990 to that in 1993?
Offer a terse response. 1.44. What is the ratio of the Population growth (in %) in Sudan in 1990 to that in 1993?
Your answer should be compact. 1.03. What is the ratio of the Population growth (in %) of Europe(all income levels) in 1991 to that in 1992?
Your response must be concise. 1.07. What is the ratio of the Population growth (in %) of Iraq in 1991 to that in 1992?
Provide a short and direct response. 0.94. What is the ratio of the Population growth (in %) in Montenegro in 1991 to that in 1992?
Keep it short and to the point. 1.17. What is the ratio of the Population growth (in %) of Sudan in 1991 to that in 1992?
Offer a terse response. 0.97. What is the ratio of the Population growth (in %) in Europe(all income levels) in 1991 to that in 1993?
Offer a terse response. 1.26. What is the ratio of the Population growth (in %) in Iraq in 1991 to that in 1993?
Give a very brief answer. 0.9. What is the ratio of the Population growth (in %) of Montenegro in 1991 to that in 1993?
Your response must be concise. 1.28. What is the ratio of the Population growth (in %) in Sudan in 1991 to that in 1993?
Your response must be concise. 1.08. What is the ratio of the Population growth (in %) of Europe(all income levels) in 1992 to that in 1993?
Offer a very short reply. 1.18. What is the ratio of the Population growth (in %) in Iraq in 1992 to that in 1993?
Ensure brevity in your answer.  0.96. What is the ratio of the Population growth (in %) in Montenegro in 1992 to that in 1993?
Offer a terse response. 1.09. What is the ratio of the Population growth (in %) in Sudan in 1992 to that in 1993?
Provide a short and direct response. 1.11. What is the difference between the highest and the second highest Population growth (in %) in Europe(all income levels)?
Your answer should be compact. 0.18. What is the difference between the highest and the second highest Population growth (in %) in Iraq?
Ensure brevity in your answer.  0.41. What is the difference between the highest and the second highest Population growth (in %) of Montenegro?
Provide a succinct answer. 0.05. What is the difference between the highest and the second highest Population growth (in %) of Sudan?
Provide a succinct answer. 0.26. What is the difference between the highest and the lowest Population growth (in %) of Europe(all income levels)?
Offer a very short reply. 0.71. What is the difference between the highest and the lowest Population growth (in %) in Iraq?
Provide a short and direct response. 1.04. What is the difference between the highest and the lowest Population growth (in %) in Montenegro?
Give a very brief answer. 1.34. What is the difference between the highest and the lowest Population growth (in %) in Sudan?
Make the answer very short. 1.29. 